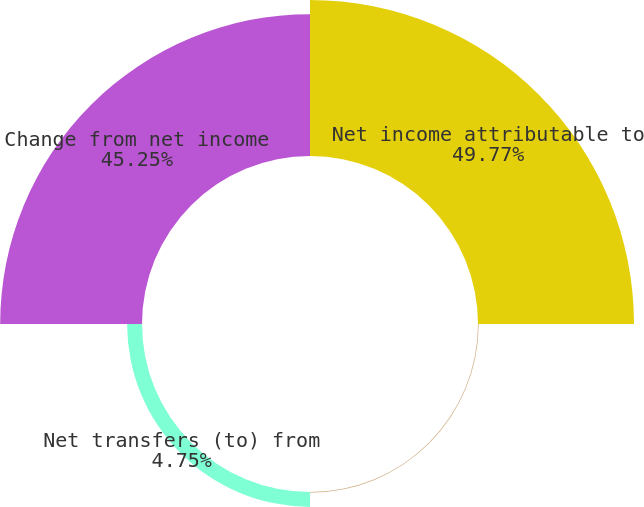Convert chart to OTSL. <chart><loc_0><loc_0><loc_500><loc_500><pie_chart><fcel>Net income attributable to<fcel>(Decrease) increase in paid-in<fcel>Net transfers (to) from<fcel>Change from net income<nl><fcel>49.77%<fcel>0.23%<fcel>4.75%<fcel>45.25%<nl></chart> 